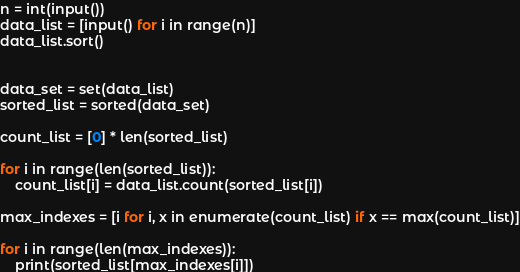<code> <loc_0><loc_0><loc_500><loc_500><_Python_>n = int(input())
data_list = [input() for i in range(n)]
data_list.sort()


data_set = set(data_list)
sorted_list = sorted(data_set)

count_list = [0] * len(sorted_list)

for i in range(len(sorted_list)):
    count_list[i] = data_list.count(sorted_list[i])

max_indexes = [i for i, x in enumerate(count_list) if x == max(count_list)]

for i in range(len(max_indexes)):
    print(sorted_list[max_indexes[i]])</code> 